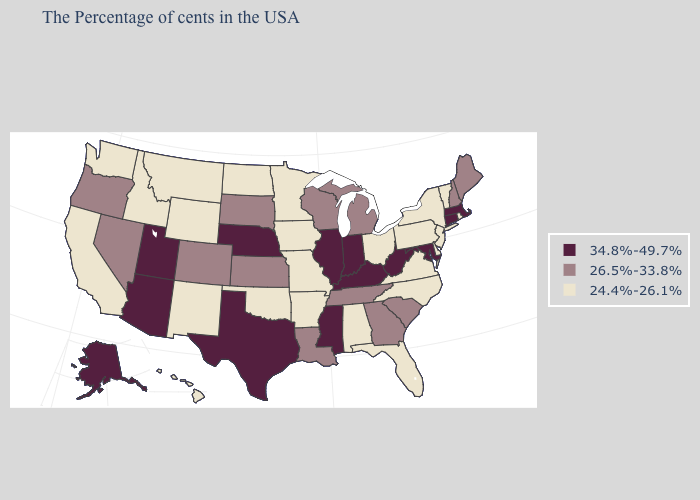What is the highest value in the MidWest ?
Write a very short answer. 34.8%-49.7%. Among the states that border Indiana , which have the highest value?
Keep it brief. Kentucky, Illinois. What is the value of Indiana?
Write a very short answer. 34.8%-49.7%. Which states have the lowest value in the South?
Be succinct. Delaware, Virginia, North Carolina, Florida, Alabama, Arkansas, Oklahoma. Does Arizona have the lowest value in the West?
Short answer required. No. Among the states that border Massachusetts , which have the lowest value?
Concise answer only. Rhode Island, Vermont, New York. Which states have the lowest value in the USA?
Answer briefly. Rhode Island, Vermont, New York, New Jersey, Delaware, Pennsylvania, Virginia, North Carolina, Ohio, Florida, Alabama, Missouri, Arkansas, Minnesota, Iowa, Oklahoma, North Dakota, Wyoming, New Mexico, Montana, Idaho, California, Washington, Hawaii. What is the lowest value in states that border Delaware?
Answer briefly. 24.4%-26.1%. What is the value of New York?
Short answer required. 24.4%-26.1%. Name the states that have a value in the range 34.8%-49.7%?
Give a very brief answer. Massachusetts, Connecticut, Maryland, West Virginia, Kentucky, Indiana, Illinois, Mississippi, Nebraska, Texas, Utah, Arizona, Alaska. Among the states that border Florida , which have the highest value?
Be succinct. Georgia. Name the states that have a value in the range 34.8%-49.7%?
Quick response, please. Massachusetts, Connecticut, Maryland, West Virginia, Kentucky, Indiana, Illinois, Mississippi, Nebraska, Texas, Utah, Arizona, Alaska. What is the value of Tennessee?
Be succinct. 26.5%-33.8%. Does the map have missing data?
Keep it brief. No. What is the value of Alaska?
Answer briefly. 34.8%-49.7%. 